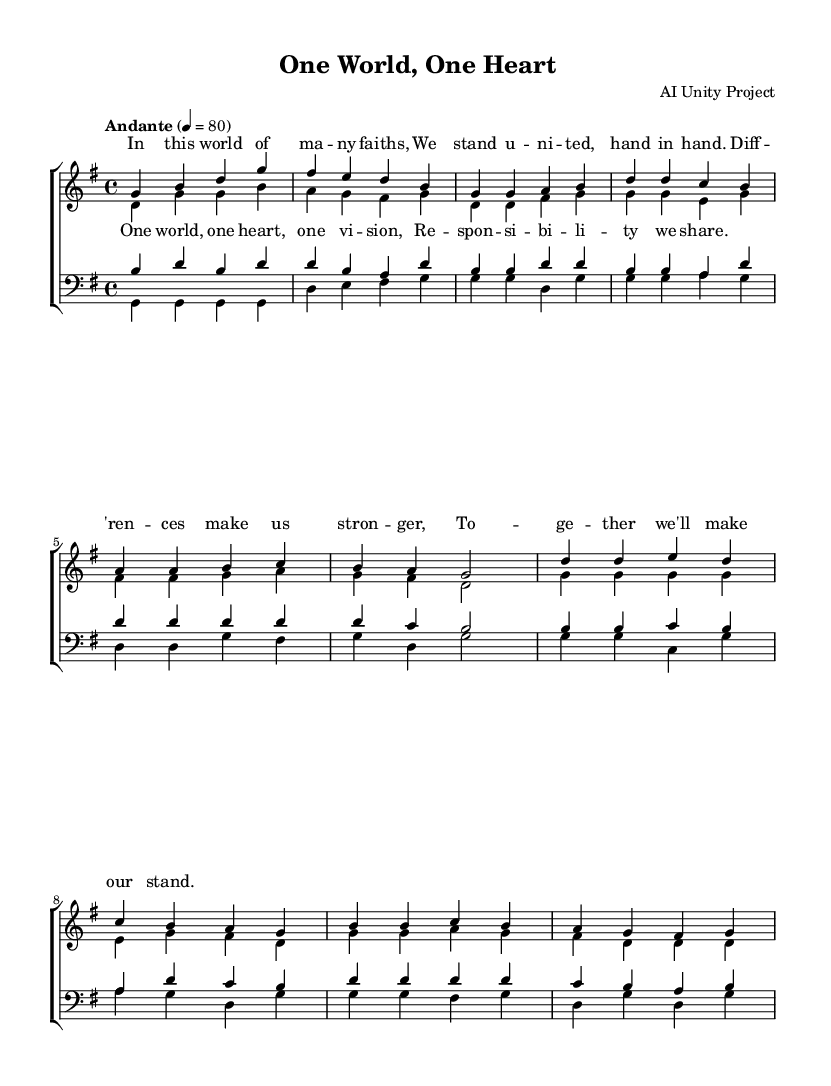What is the key signature of this music? The key signature is G major, which has one sharp, F#. This can be determined from the global section of the code where it specifies \key g \major.
Answer: G major What is the time signature of this music? The time signature is 4/4, indicated in the global section of the code with \time 4/4.
Answer: 4/4 What is the tempo marking for this piece? The tempo marking is "Andante," which is indicated in the global section of the code with \tempo "Andante" 4 = 80.
Answer: Andante How many verses are included in the lyrics? There is one verse included in the lyrics before the chorus. This can be seen in the lyriсmode section where the verse is defined separately from the chorus.
Answer: One verse What is the main theme of the song as indicated by the lyrics? The main theme is unity and social responsibility among different faiths, as evident in the lyrics that speak about standing united and sharing responsibility.
Answer: Unity and social responsibility What musical voices are present in this choral arrangement? The choral arrangement includes soprano, alto, tenor, and bass voices, as specified in the creation of the ChoirStaff and the individual voice assignments in the score.
Answer: Soprano, alto, tenor, bass What is the last note of the soprano voice part in the chorus? The last note of the soprano voice part in the chorus is a G, as indicated by the final note in the snippet of music for the soprano voice.
Answer: G 